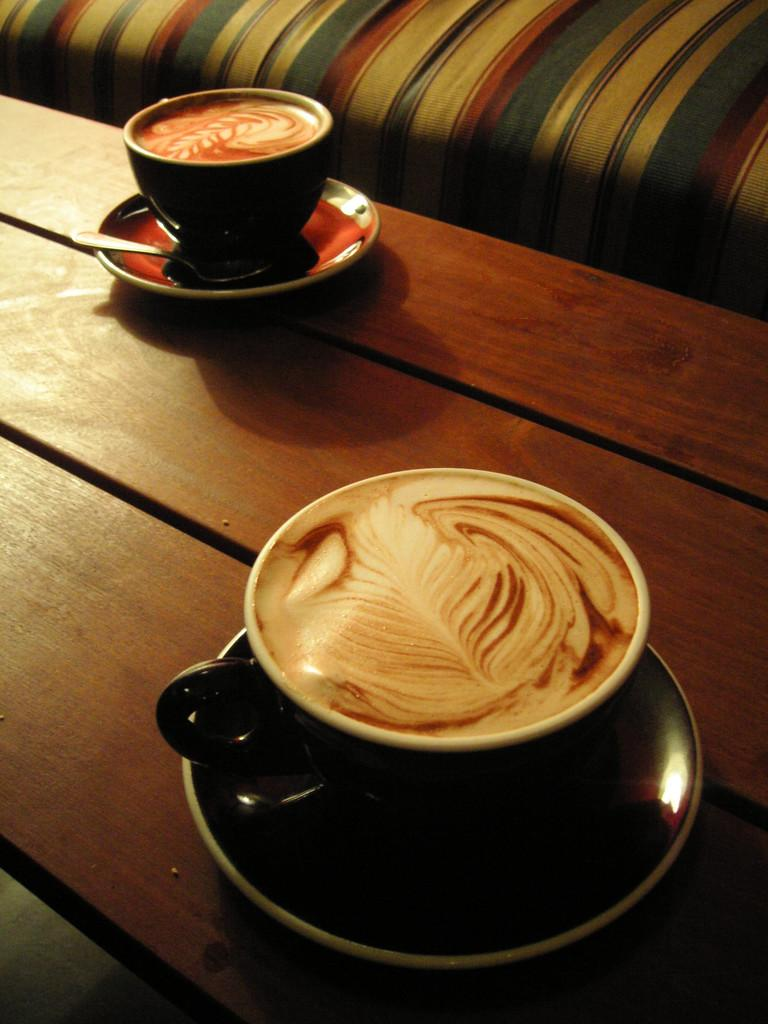How many coffee cups are visible in the image? There are two coffee cups in the image. What is inside the coffee cups? Coffee is present in the coffee cups. Where is the lettuce being prepared in the image? There is no lettuce or any indication of food preparation in the image; it only features two coffee cups with coffee. 